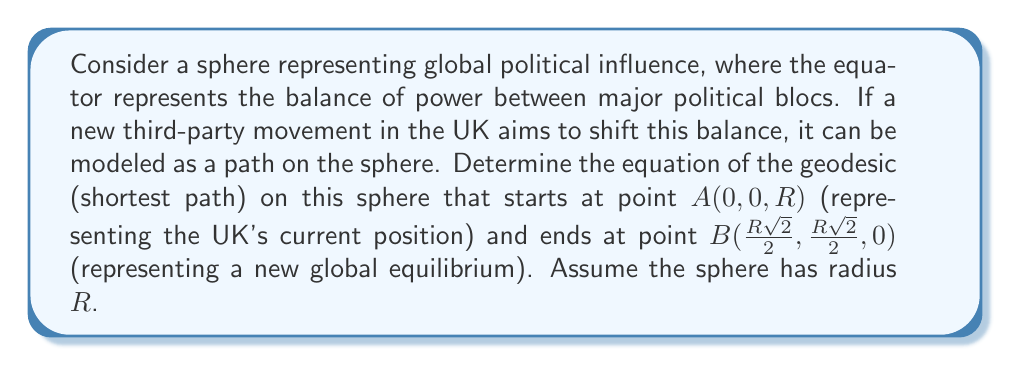Help me with this question. To find the geodesic on a sphere, we follow these steps:

1) Geodesics on a sphere are great circles, which are intersections of the sphere with planes passing through its center.

2) We need to find the equation of the plane containing points $A$, $B$, and the center of the sphere $(0,0,0)$.

3) The normal vector to this plane can be found by the cross product of vectors $\vec{OA}$ and $\vec{OB}$:

   $$\vec{n} = \vec{OA} \times \vec{OB} = \begin{vmatrix} 
   i & j & k \\
   0 & 0 & R \\
   \frac{R\sqrt{2}}{2} & \frac{R\sqrt{2}}{2} & 0
   \end{vmatrix}$$

4) Calculating this cross product:

   $$\vec{n} = (-\frac{R^2\sqrt{2}}{2}, \frac{R^2\sqrt{2}}{2}, 0)$$

5) The equation of the plane is therefore:

   $$-\frac{R\sqrt{2}}{2}x + \frac{R\sqrt{2}}{2}y = 0$$

6) Simplifying:

   $$x = y$$

7) The geodesic is the intersection of this plane with the sphere. The equation of the sphere is:

   $$x^2 + y^2 + z^2 = R^2$$

8) Substituting $x = y$ into the sphere equation:

   $$2x^2 + z^2 = R^2$$

9) This is the equation of the geodesic in implicit form. We can parameterize it as:

   $$x = y = \frac{R\sin(t)}{\sqrt{2}}, z = R\cos(t)$$

   where $t$ is the parameter varying from $0$ to $\frac{\pi}{2}$.
Answer: $$x = y = \frac{R\sin(t)}{\sqrt{2}}, z = R\cos(t), \text{ where } 0 \leq t \leq \frac{\pi}{2}$$ 